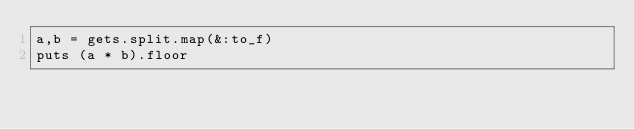<code> <loc_0><loc_0><loc_500><loc_500><_Ruby_>a,b = gets.split.map(&:to_f)
puts (a * b).floor
</code> 